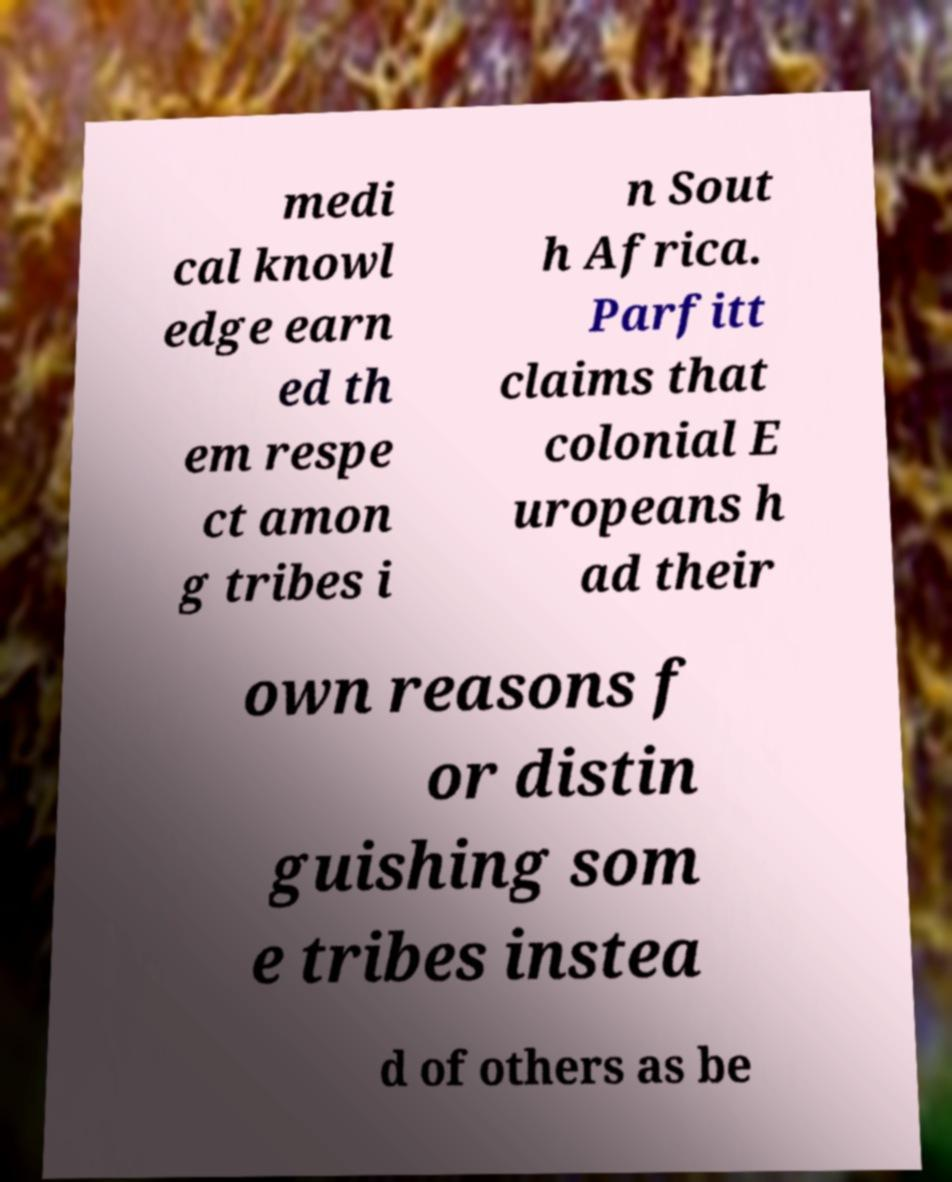For documentation purposes, I need the text within this image transcribed. Could you provide that? medi cal knowl edge earn ed th em respe ct amon g tribes i n Sout h Africa. Parfitt claims that colonial E uropeans h ad their own reasons f or distin guishing som e tribes instea d of others as be 